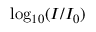<formula> <loc_0><loc_0><loc_500><loc_500>\log _ { 1 0 } ( I / I _ { 0 } )</formula> 